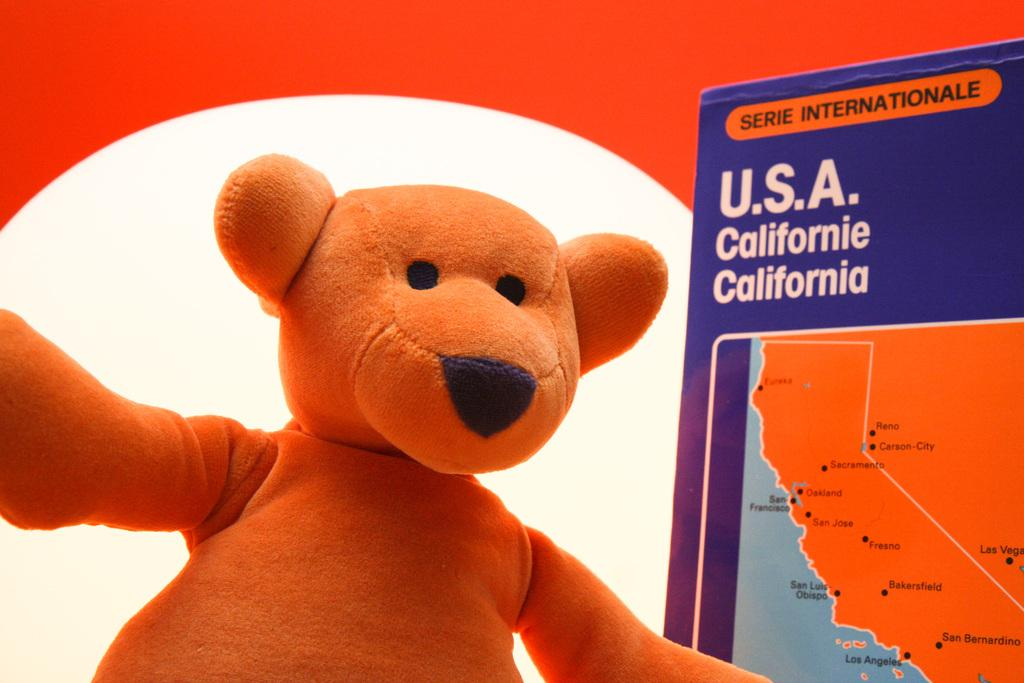What is the main subject of the image? There is a doll in the image. What else can be seen in the image besides the doll? There is a board with text in the image. Can you describe the background of the image? The background of the image includes white and red colors. How many horses can be seen in the image? There are no horses present in the image. What word is written on the board in the image? The provided facts do not include the text on the board, so we cannot answer this question definitively. 